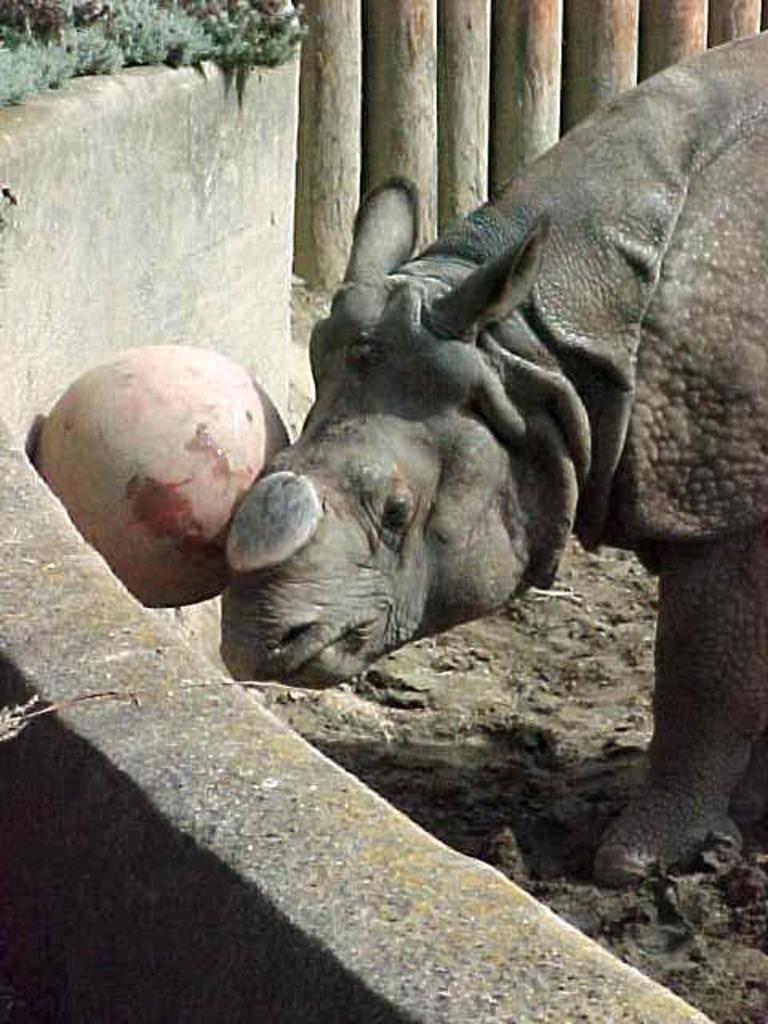What animal is in the picture? There is a rhinoceros in the picture. What can be seen on the left side of the picture? There is an object on the left side of the picture. What is in the background of the picture? There is a wall in the picture. What type of vegetation is present in the picture? There are plants in the picture. What is on the floor in the picture? There is soil on the floor in the picture. What type of lettuce is being used as a decoration on the rhinoceros's horn in the picture? There is no lettuce present in the image, and the rhinoceros's horn is not being used as a decoration. 